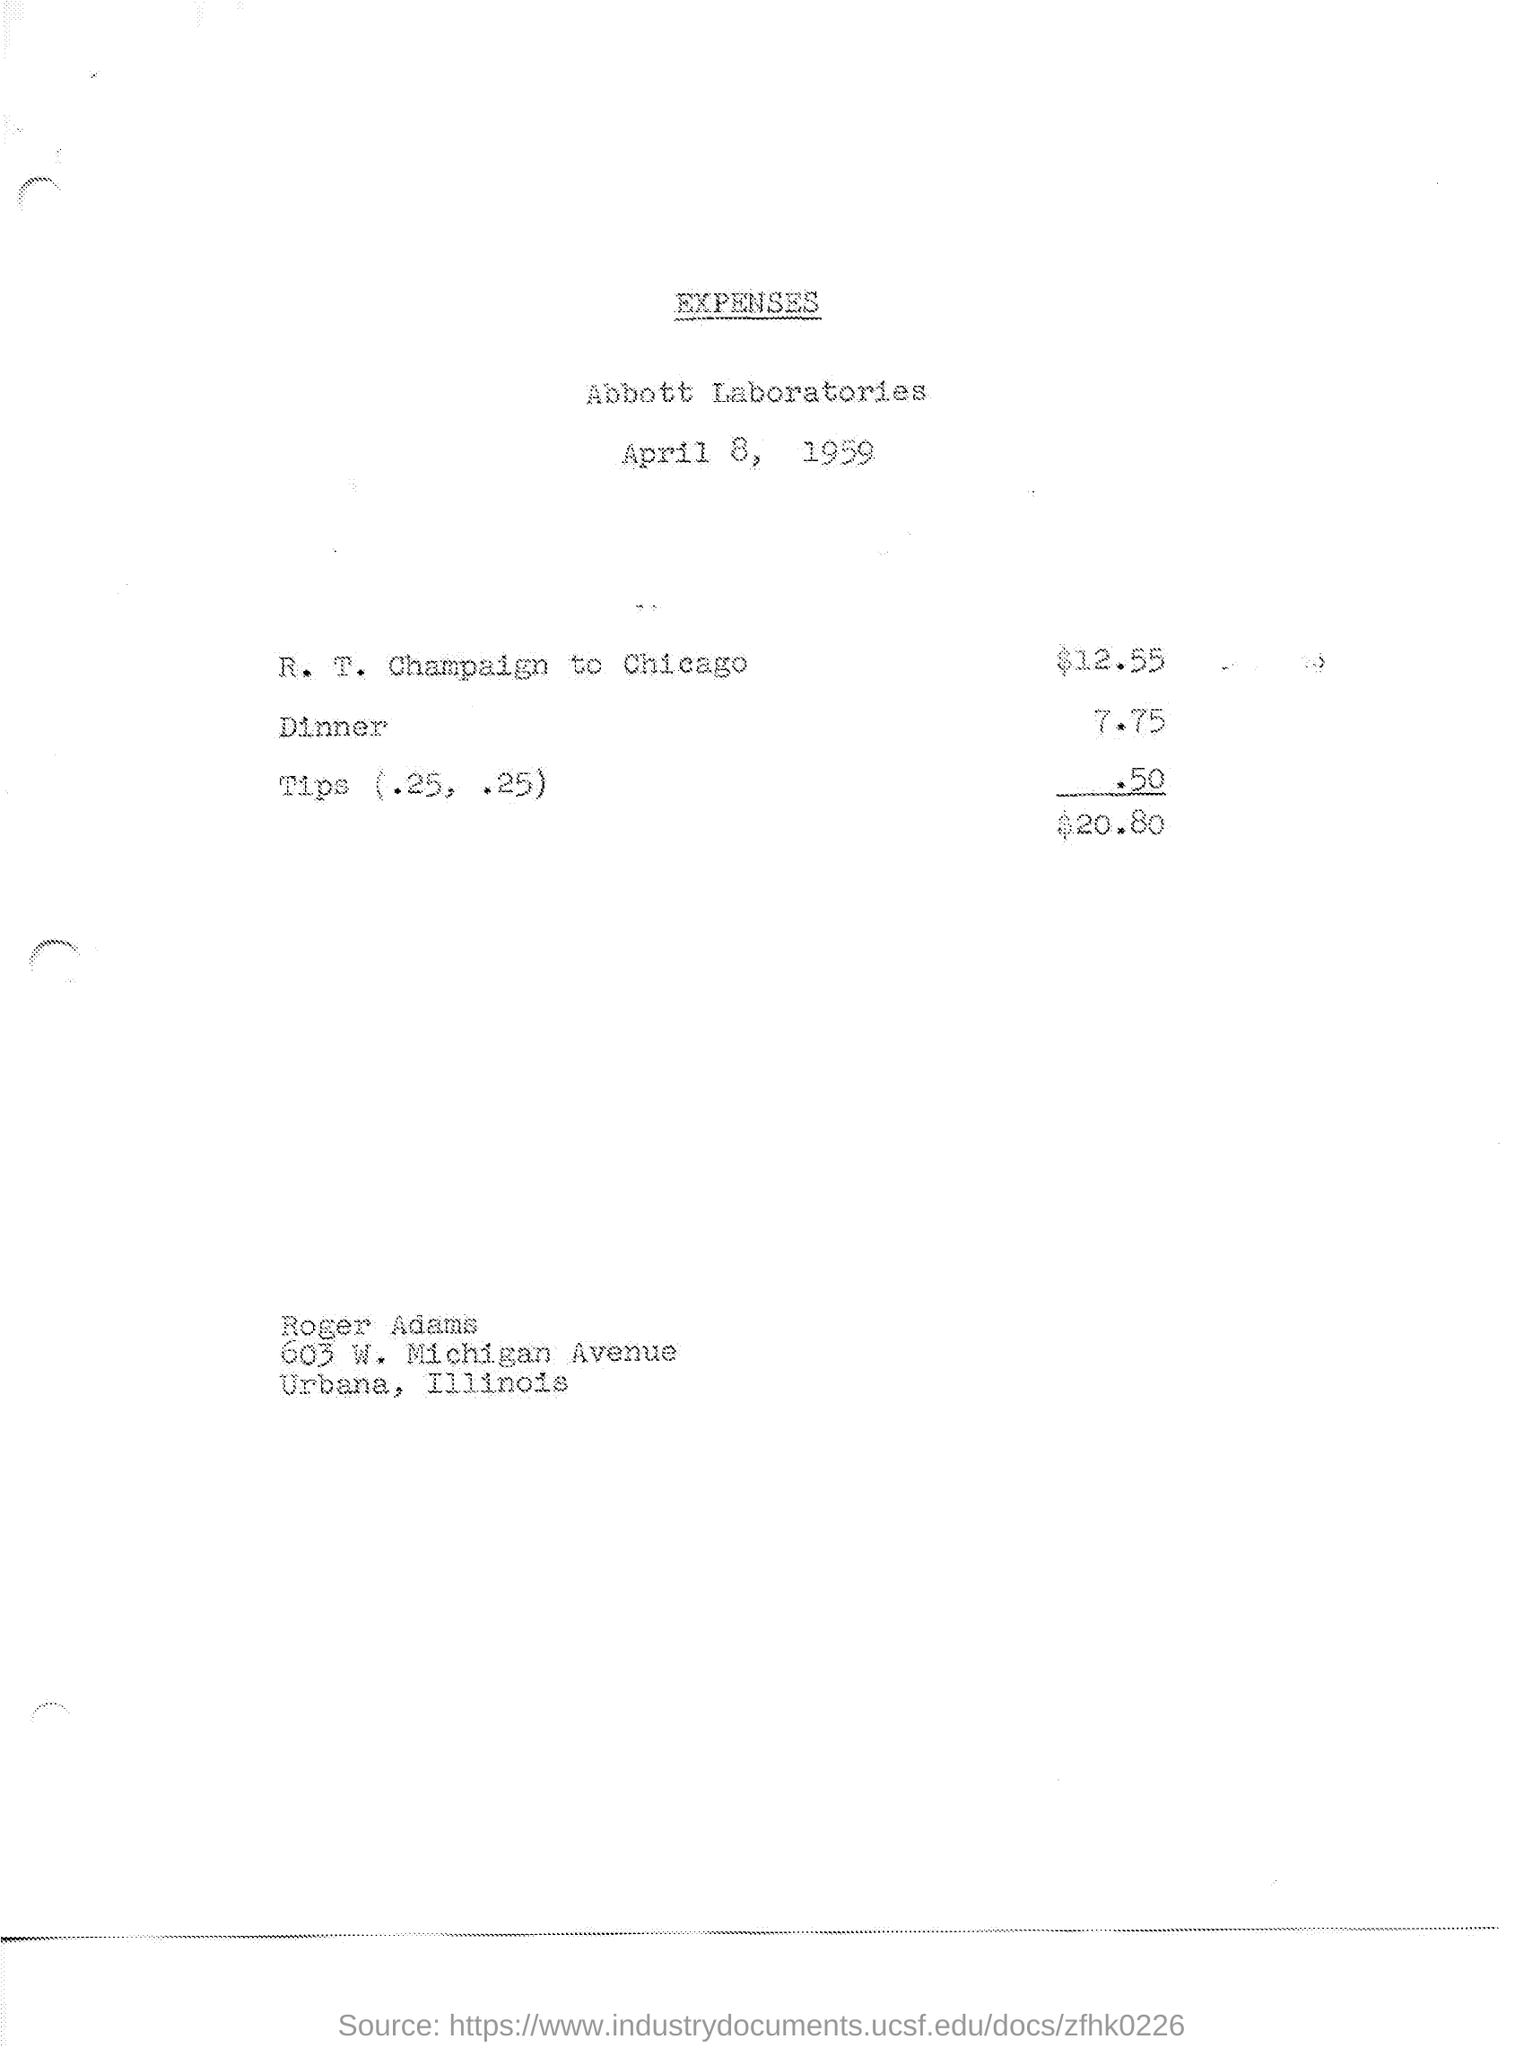What is the total amount spent on dinner? The total amount spent on dinner, as shown in the image, is $7.75. 